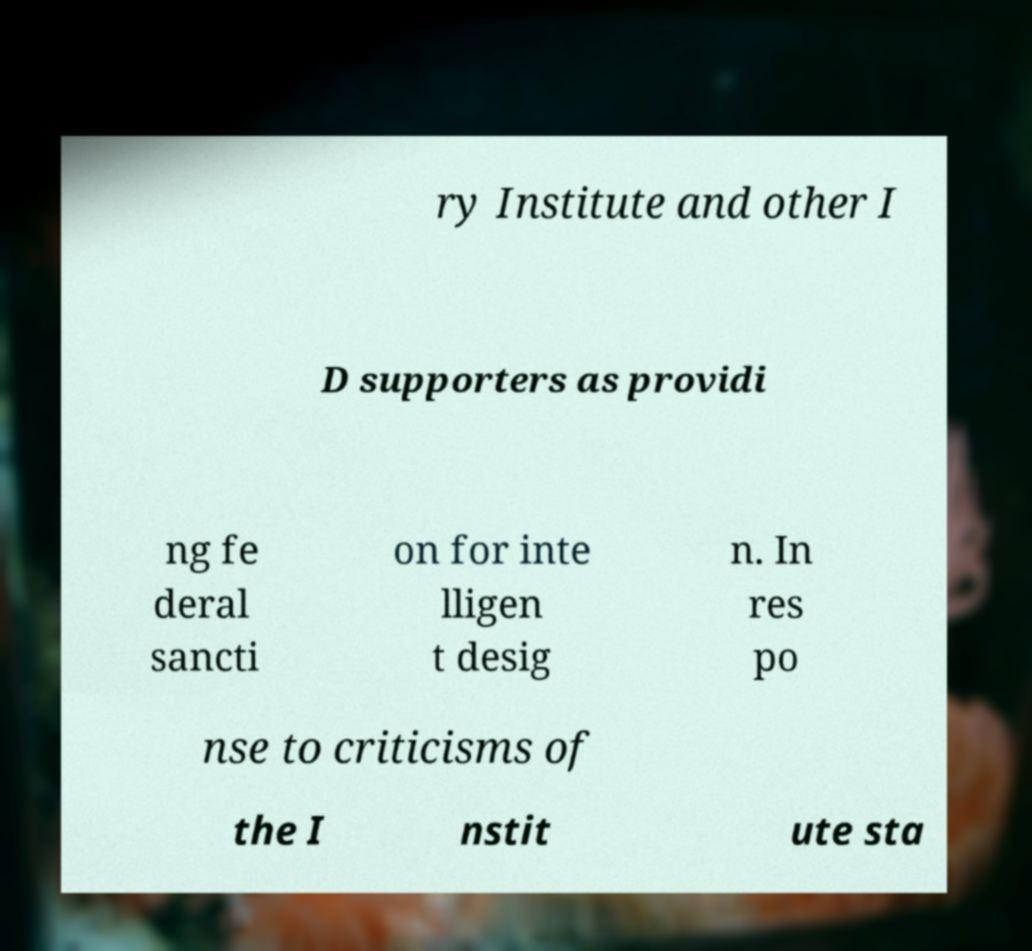Could you extract and type out the text from this image? ry Institute and other I D supporters as providi ng fe deral sancti on for inte lligen t desig n. In res po nse to criticisms of the I nstit ute sta 